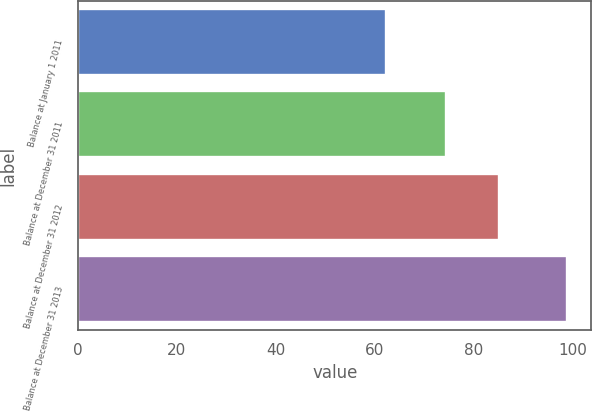Convert chart to OTSL. <chart><loc_0><loc_0><loc_500><loc_500><bar_chart><fcel>Balance at January 1 2011<fcel>Balance at December 31 2011<fcel>Balance at December 31 2012<fcel>Balance at December 31 2013<nl><fcel>62.3<fcel>74.4<fcel>85.1<fcel>98.8<nl></chart> 